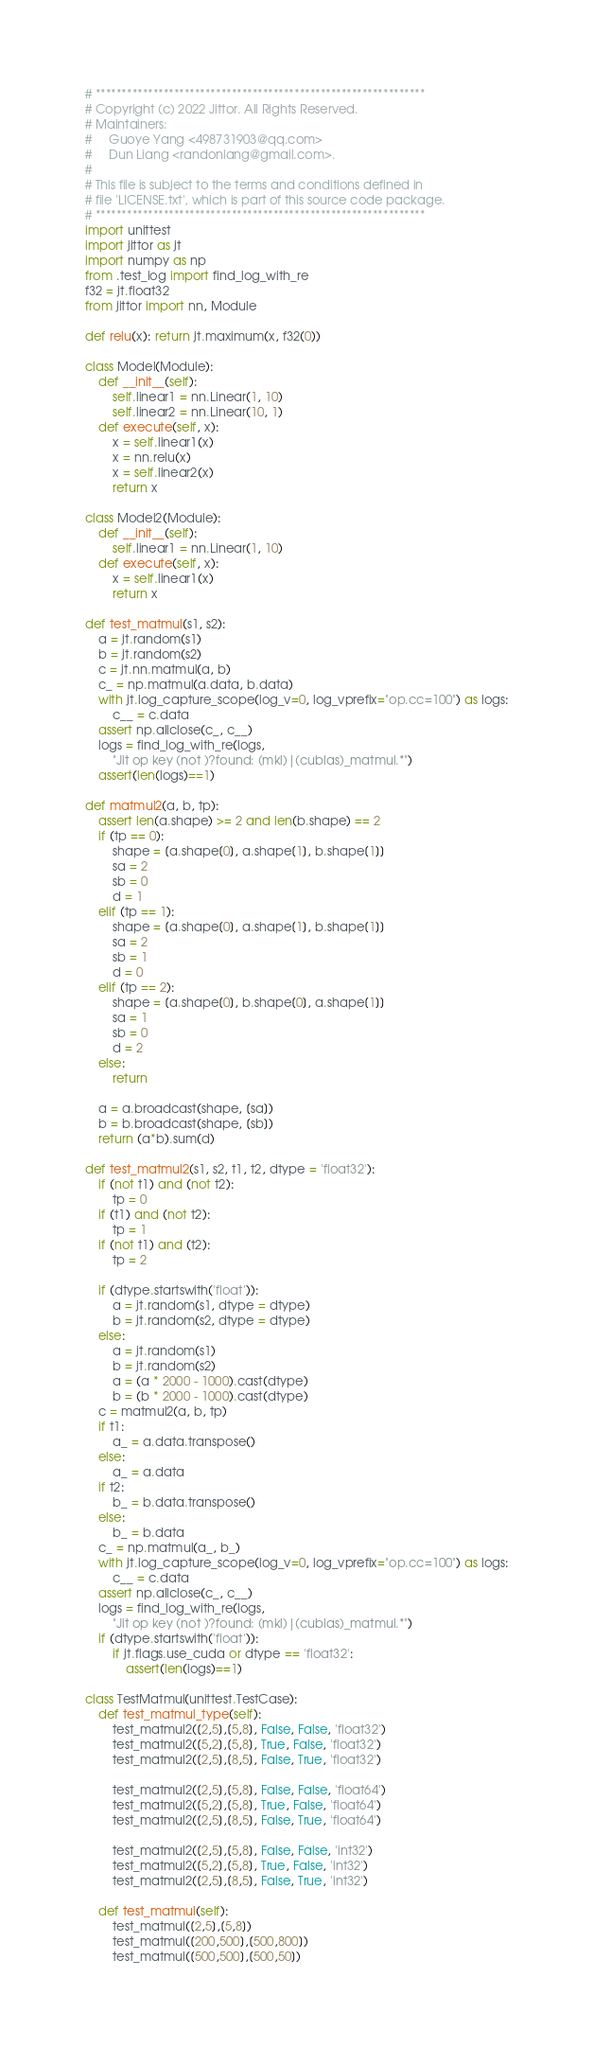<code> <loc_0><loc_0><loc_500><loc_500><_Python_># ***************************************************************
# Copyright (c) 2022 Jittor. All Rights Reserved. 
# Maintainers: 
#     Guoye Yang <498731903@qq.com>
#     Dun Liang <randonlang@gmail.com>. 
# 
# This file is subject to the terms and conditions defined in
# file 'LICENSE.txt', which is part of this source code package.
# ***************************************************************
import unittest
import jittor as jt
import numpy as np
from .test_log import find_log_with_re
f32 = jt.float32
from jittor import nn, Module
    
def relu(x): return jt.maximum(x, f32(0))

class Model(Module):
    def __init__(self):
        self.linear1 = nn.Linear(1, 10)
        self.linear2 = nn.Linear(10, 1)
    def execute(self, x):
        x = self.linear1(x)
        x = nn.relu(x)
        x = self.linear2(x)
        return x

class Model2(Module):
    def __init__(self):
        self.linear1 = nn.Linear(1, 10)
    def execute(self, x):
        x = self.linear1(x)
        return x

def test_matmul(s1, s2):
    a = jt.random(s1)
    b = jt.random(s2)
    c = jt.nn.matmul(a, b)
    c_ = np.matmul(a.data, b.data)
    with jt.log_capture_scope(log_v=0, log_vprefix="op.cc=100") as logs:
        c__ = c.data
    assert np.allclose(c_, c__)
    logs = find_log_with_re(logs, 
        "Jit op key (not )?found: (mkl)|(cublas)_matmul.*")
    assert(len(logs)==1)

def matmul2(a, b, tp):
    assert len(a.shape) >= 2 and len(b.shape) == 2
    if (tp == 0):
        shape = [a.shape[0], a.shape[1], b.shape[1]]
        sa = 2
        sb = 0
        d = 1
    elif (tp == 1):
        shape = [a.shape[0], a.shape[1], b.shape[1]]
        sa = 2
        sb = 1
        d = 0
    elif (tp == 2):
        shape = [a.shape[0], b.shape[0], a.shape[1]]
        sa = 1
        sb = 0
        d = 2
    else:
        return

    a = a.broadcast(shape, [sa])
    b = b.broadcast(shape, [sb])
    return (a*b).sum(d)

def test_matmul2(s1, s2, t1, t2, dtype = 'float32'):
    if (not t1) and (not t2):
        tp = 0
    if (t1) and (not t2):
        tp = 1
    if (not t1) and (t2):
        tp = 2

    if (dtype.startswith('float')):
        a = jt.random(s1, dtype = dtype)
        b = jt.random(s2, dtype = dtype)
    else:
        a = jt.random(s1)
        b = jt.random(s2)
        a = (a * 2000 - 1000).cast(dtype)
        b = (b * 2000 - 1000).cast(dtype)
    c = matmul2(a, b, tp)
    if t1:
        a_ = a.data.transpose()
    else:
        a_ = a.data
    if t2:
        b_ = b.data.transpose()
    else:
        b_ = b.data  
    c_ = np.matmul(a_, b_)
    with jt.log_capture_scope(log_v=0, log_vprefix="op.cc=100") as logs:
        c__ = c.data
    assert np.allclose(c_, c__)
    logs = find_log_with_re(logs, 
        "Jit op key (not )?found: (mkl)|(cublas)_matmul.*")
    if (dtype.startswith('float')):
        if jt.flags.use_cuda or dtype == 'float32':
            assert(len(logs)==1)

class TestMatmul(unittest.TestCase):
    def test_matmul_type(self):
        test_matmul2([2,5],[5,8], False, False, 'float32')
        test_matmul2([5,2],[5,8], True, False, 'float32')
        test_matmul2([2,5],[8,5], False, True, 'float32')

        test_matmul2([2,5],[5,8], False, False, 'float64')
        test_matmul2([5,2],[5,8], True, False, 'float64')
        test_matmul2([2,5],[8,5], False, True, 'float64')

        test_matmul2([2,5],[5,8], False, False, 'int32')
        test_matmul2([5,2],[5,8], True, False, 'int32')
        test_matmul2([2,5],[8,5], False, True, 'int32')

    def test_matmul(self):
        test_matmul([2,5],[5,8])
        test_matmul([200,500],[500,800])
        test_matmul([500,500],[500,50])</code> 